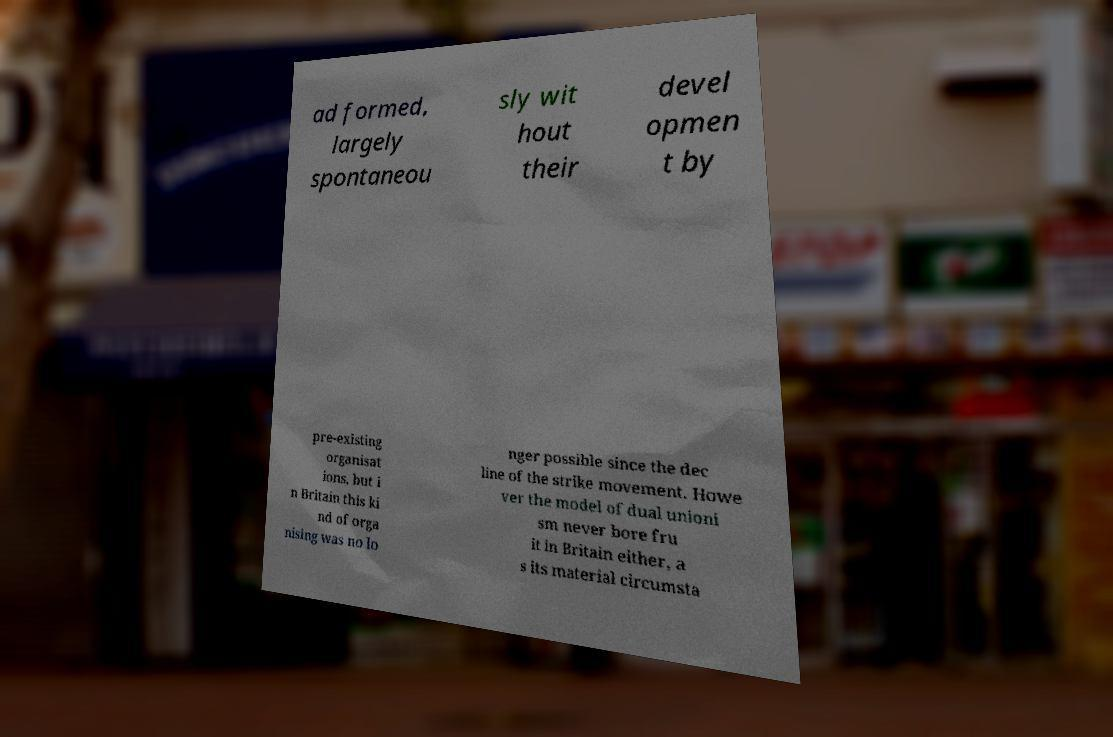Can you read and provide the text displayed in the image?This photo seems to have some interesting text. Can you extract and type it out for me? ad formed, largely spontaneou sly wit hout their devel opmen t by pre-existing organisat ions, but i n Britain this ki nd of orga nising was no lo nger possible since the dec line of the strike movement. Howe ver the model of dual unioni sm never bore fru it in Britain either, a s its material circumsta 